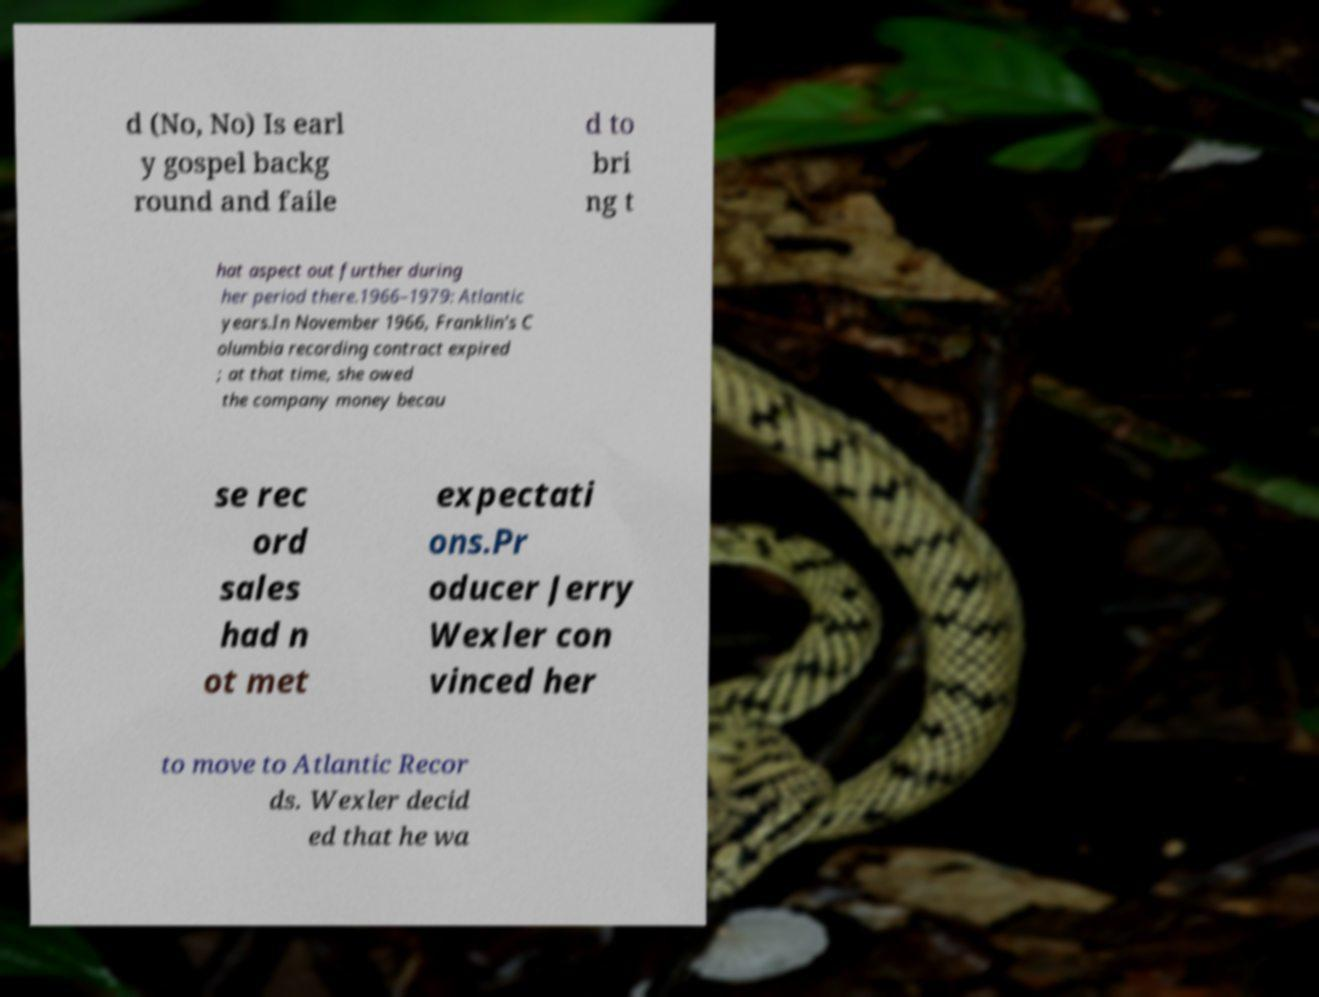Please identify and transcribe the text found in this image. d (No, No) Is earl y gospel backg round and faile d to bri ng t hat aspect out further during her period there.1966–1979: Atlantic years.In November 1966, Franklin's C olumbia recording contract expired ; at that time, she owed the company money becau se rec ord sales had n ot met expectati ons.Pr oducer Jerry Wexler con vinced her to move to Atlantic Recor ds. Wexler decid ed that he wa 